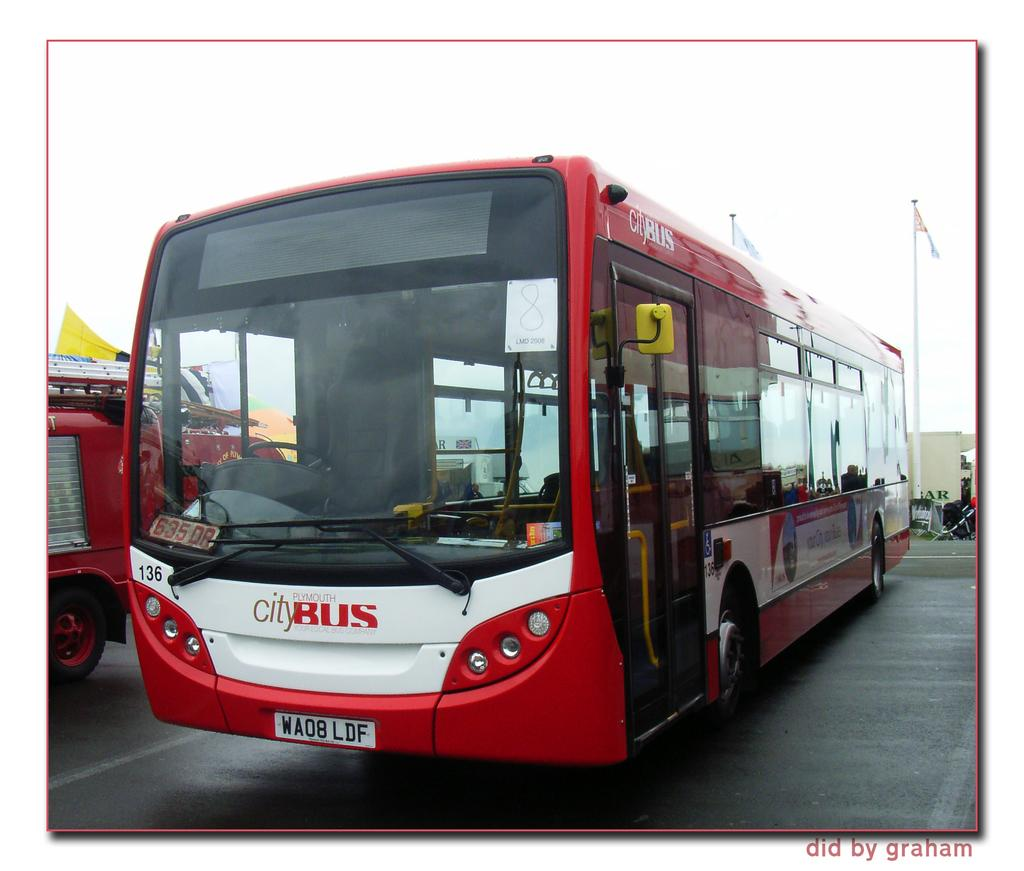<image>
Render a clear and concise summary of the photo. A Plymouth City bus is red and white. 